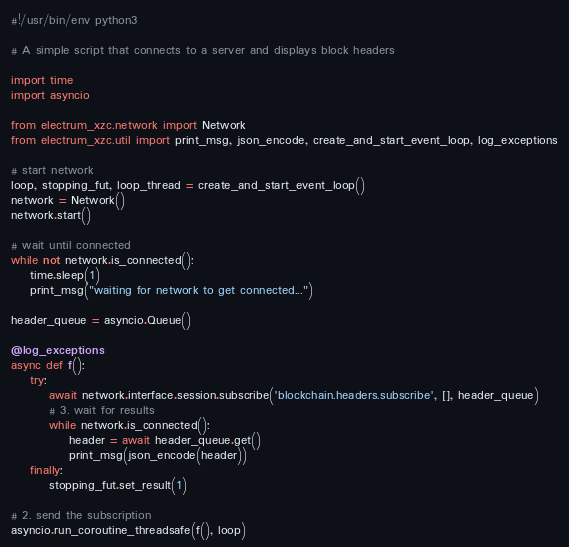Convert code to text. <code><loc_0><loc_0><loc_500><loc_500><_Python_>#!/usr/bin/env python3

# A simple script that connects to a server and displays block headers

import time
import asyncio

from electrum_xzc.network import Network
from electrum_xzc.util import print_msg, json_encode, create_and_start_event_loop, log_exceptions

# start network
loop, stopping_fut, loop_thread = create_and_start_event_loop()
network = Network()
network.start()

# wait until connected
while not network.is_connected():
    time.sleep(1)
    print_msg("waiting for network to get connected...")

header_queue = asyncio.Queue()

@log_exceptions
async def f():
    try:
        await network.interface.session.subscribe('blockchain.headers.subscribe', [], header_queue)
        # 3. wait for results
        while network.is_connected():
            header = await header_queue.get()
            print_msg(json_encode(header))
    finally:
        stopping_fut.set_result(1)

# 2. send the subscription
asyncio.run_coroutine_threadsafe(f(), loop)
</code> 